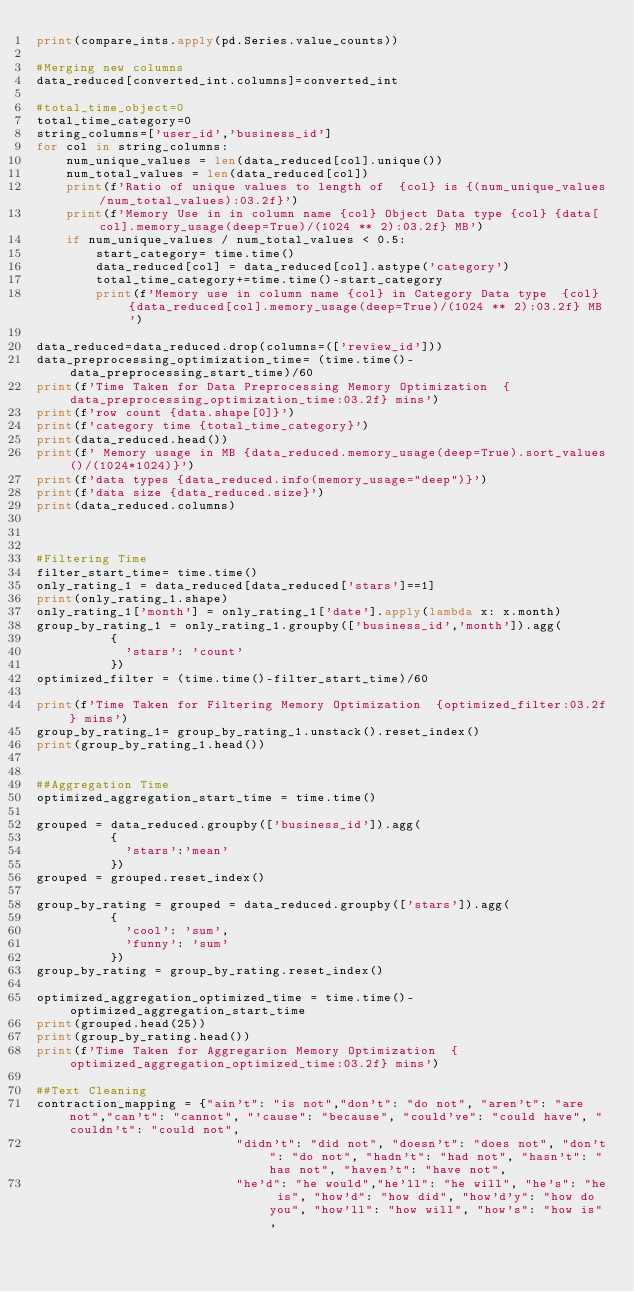<code> <loc_0><loc_0><loc_500><loc_500><_Python_>print(compare_ints.apply(pd.Series.value_counts))

#Merging new columns
data_reduced[converted_int.columns]=converted_int

#total_time_object=0
total_time_category=0
string_columns=['user_id','business_id']
for col in string_columns:
    num_unique_values = len(data_reduced[col].unique())
    num_total_values = len(data_reduced[col])
    print(f'Ratio of unique values to length of  {col} is {(num_unique_values/num_total_values):03.2f}')
    print(f'Memory Use in in column name {col} Object Data type {col} {data[col].memory_usage(deep=True)/(1024 ** 2):03.2f} MB')
    if num_unique_values / num_total_values < 0.5:
        start_category= time.time()
        data_reduced[col] = data_reduced[col].astype('category')
        total_time_category+=time.time()-start_category
        print(f'Memory use in column name {col} in Category Data type  {col} {data_reduced[col].memory_usage(deep=True)/(1024 ** 2):03.2f} MB')

data_reduced=data_reduced.drop(columns=(['review_id']))
data_preprocessing_optimization_time= (time.time()-data_preprocessing_start_time)/60
print(f'Time Taken for Data Preprocessing Memory Optimization  {data_preprocessing_optimization_time:03.2f} mins')
print(f'row count {data.shape[0]}')
print(f'category time {total_time_category}')
print(data_reduced.head())
print(f' Memory usage in MB {data_reduced.memory_usage(deep=True).sort_values()/(1024*1024)}')
print(f'data types {data_reduced.info(memory_usage="deep")}')
print(f'data size {data_reduced.size}')
print(data_reduced.columns)



#Filtering Time 
filter_start_time= time.time()
only_rating_1 = data_reduced[data_reduced['stars']==1]
print(only_rating_1.shape)
only_rating_1['month'] = only_rating_1['date'].apply(lambda x: x.month)
group_by_rating_1 = only_rating_1.groupby(['business_id','month']).agg(
          {
            'stars': 'count'
          })
optimized_filter = (time.time()-filter_start_time)/60

print(f'Time Taken for Filtering Memory Optimization  {optimized_filter:03.2f} mins')
group_by_rating_1= group_by_rating_1.unstack().reset_index()
print(group_by_rating_1.head())


##Aggregation Time
optimized_aggregation_start_time = time.time()

grouped = data_reduced.groupby(['business_id']).agg(
          {
            'stars':'mean'
          })
grouped = grouped.reset_index()

group_by_rating = grouped = data_reduced.groupby(['stars']).agg(
          {
            'cool': 'sum',
            'funny': 'sum'
          })
group_by_rating = group_by_rating.reset_index()

optimized_aggregation_optimized_time = time.time()-optimized_aggregation_start_time
print(grouped.head(25))
print(group_by_rating.head())
print(f'Time Taken for Aggregarion Memory Optimization  {optimized_aggregation_optimized_time:03.2f} mins')

##Text Cleaning
contraction_mapping = {"ain't": "is not","don't": "do not", "aren't": "are not","can't": "cannot", "'cause": "because", "could've": "could have", "couldn't": "could not",
                           "didn't": "did not", "doesn't": "does not", "don't": "do not", "hadn't": "had not", "hasn't": "has not", "haven't": "have not",
                           "he'd": "he would","he'll": "he will", "he's": "he is", "how'd": "how did", "how'd'y": "how do you", "how'll": "how will", "how's": "how is",</code> 